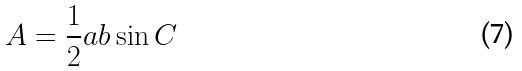Convert formula to latex. <formula><loc_0><loc_0><loc_500><loc_500>A = \frac { 1 } { 2 } a b \sin C</formula> 